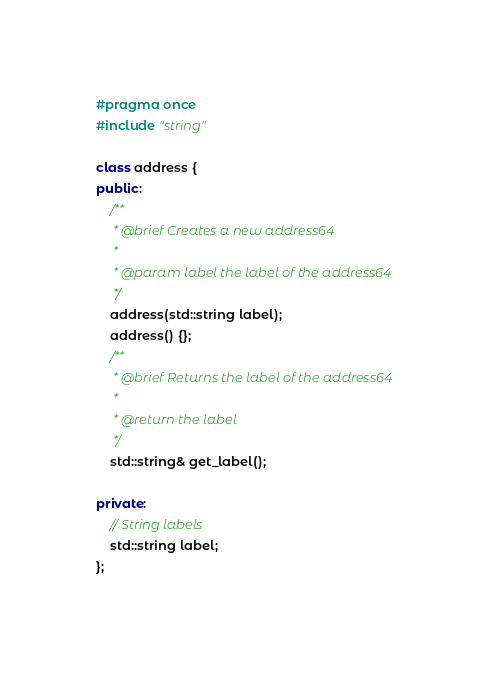Convert code to text. <code><loc_0><loc_0><loc_500><loc_500><_C++_>#pragma once
#include "string"

class address {
public:
    /**
     * @brief Creates a new address64
     * 
     * @param label the label of the address64
     */
    address(std::string label);
    address() {};
    /**
     * @brief Returns the label of the address64
     * 
     * @return the label 
     */
    std::string& get_label();

private:    
    // String labels
    std::string label;
};
</code> 